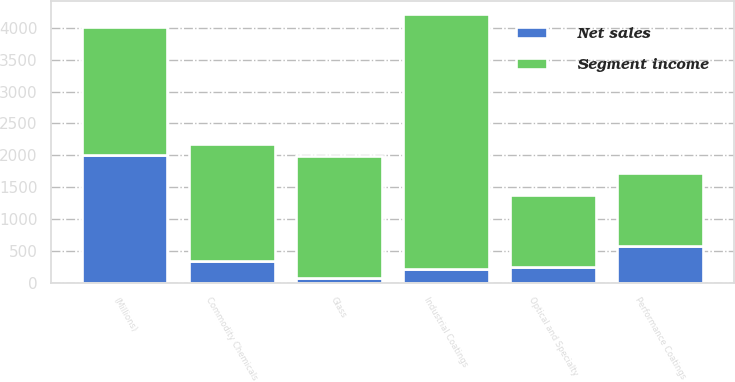Convert chart to OTSL. <chart><loc_0><loc_0><loc_500><loc_500><stacked_bar_chart><ecel><fcel>(Millions)<fcel>Performance Coatings<fcel>Industrial Coatings<fcel>Optical and Specialty<fcel>Commodity Chemicals<fcel>Glass<nl><fcel>Segment income<fcel>2008<fcel>1134<fcel>3999<fcel>1134<fcel>1837<fcel>1914<nl><fcel>Net sales<fcel>2008<fcel>582<fcel>212<fcel>244<fcel>340<fcel>70<nl></chart> 